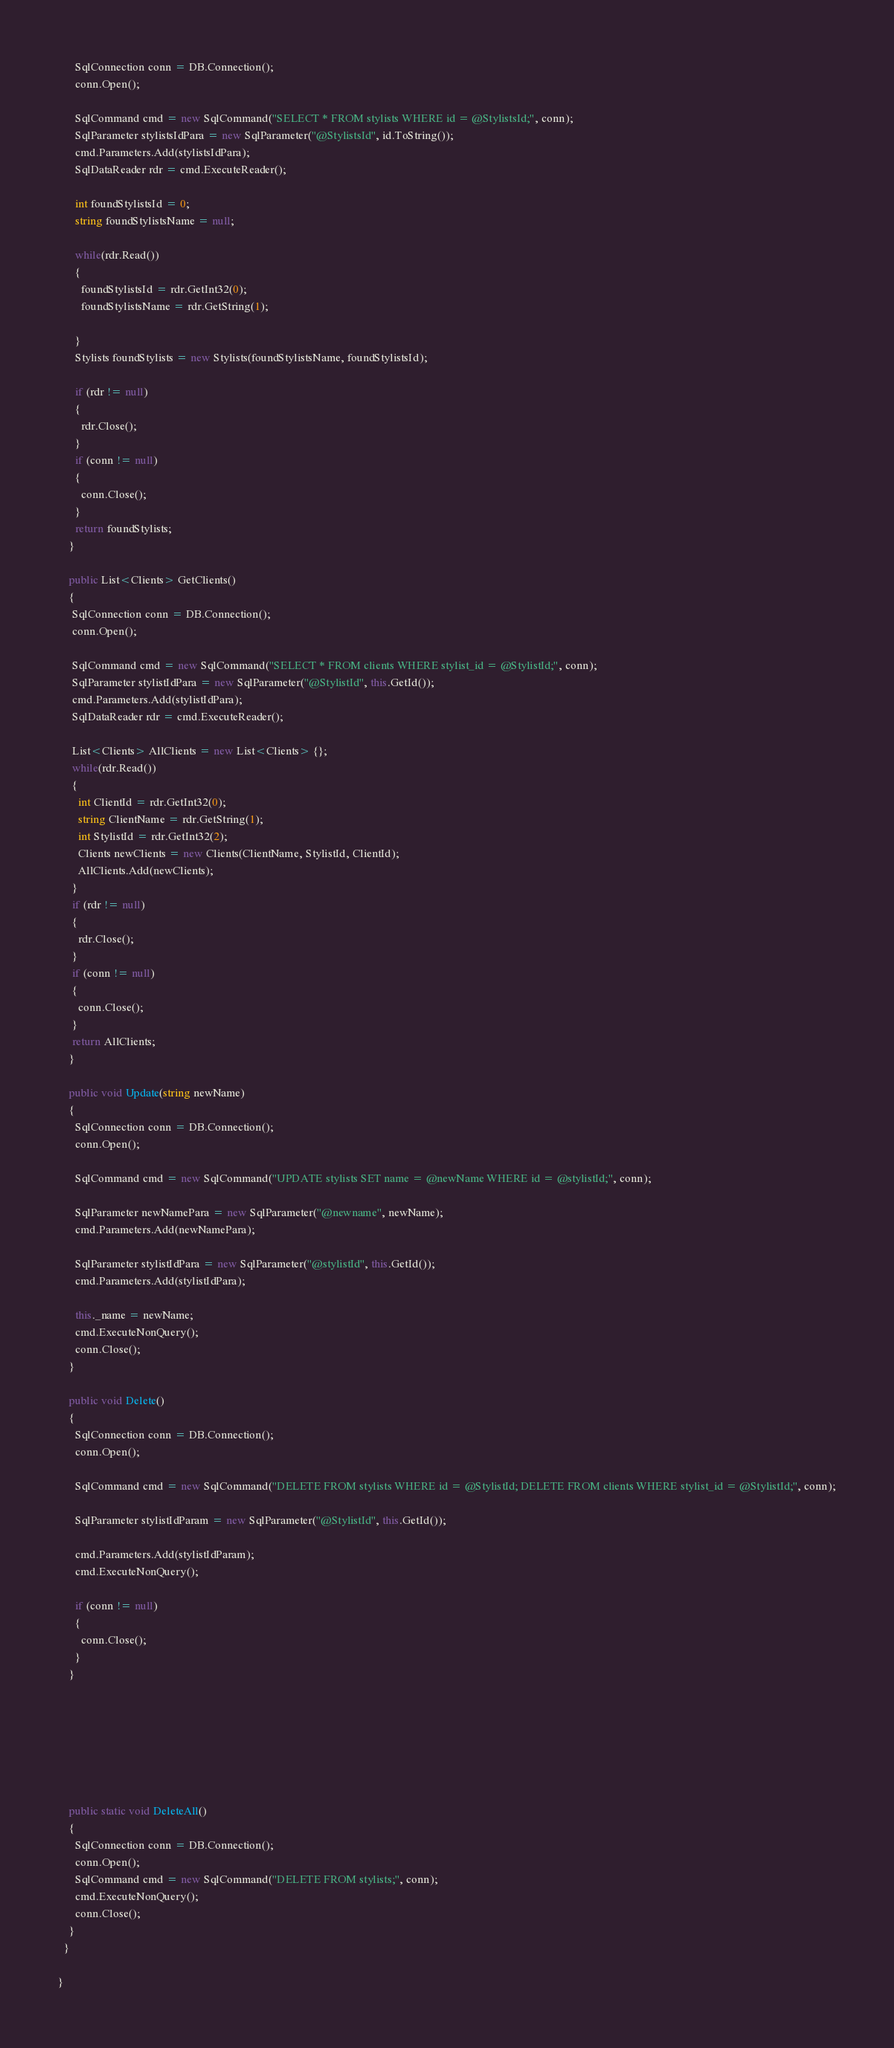<code> <loc_0><loc_0><loc_500><loc_500><_C#_>      SqlConnection conn = DB.Connection();
      conn.Open();

      SqlCommand cmd = new SqlCommand("SELECT * FROM stylists WHERE id = @StylistsId;", conn);
      SqlParameter stylistsIdPara = new SqlParameter("@StylistsId", id.ToString());
      cmd.Parameters.Add(stylistsIdPara);
      SqlDataReader rdr = cmd.ExecuteReader();

      int foundStylistsId = 0;
      string foundStylistsName = null;

      while(rdr.Read())
      {
        foundStylistsId = rdr.GetInt32(0);
        foundStylistsName = rdr.GetString(1);

      }
      Stylists foundStylists = new Stylists(foundStylistsName, foundStylistsId);

      if (rdr != null)
      {
        rdr.Close();
      }
      if (conn != null)
      {
        conn.Close();
      }
      return foundStylists;
    }

    public List<Clients> GetClients()
    {
     SqlConnection conn = DB.Connection();
     conn.Open();

     SqlCommand cmd = new SqlCommand("SELECT * FROM clients WHERE stylist_id = @StylistId;", conn);
     SqlParameter stylistIdPara = new SqlParameter("@StylistId", this.GetId());
     cmd.Parameters.Add(stylistIdPara);
     SqlDataReader rdr = cmd.ExecuteReader();

     List<Clients> AllClients = new List<Clients> {};
     while(rdr.Read())
     {
       int ClientId = rdr.GetInt32(0);
       string ClientName = rdr.GetString(1);
       int StylistId = rdr.GetInt32(2);
       Clients newClients = new Clients(ClientName, StylistId, ClientId);
       AllClients.Add(newClients);
     }
     if (rdr != null)
     {
       rdr.Close();
     }
     if (conn != null)
     {
       conn.Close();
     }
     return AllClients;
    }

    public void Update(string newName)
    {
      SqlConnection conn = DB.Connection();
      conn.Open();

      SqlCommand cmd = new SqlCommand("UPDATE stylists SET name = @newName WHERE id = @stylistId;", conn);

      SqlParameter newNamePara = new SqlParameter("@newname", newName);
      cmd.Parameters.Add(newNamePara);

      SqlParameter stylistIdPara = new SqlParameter("@stylistId", this.GetId());
      cmd.Parameters.Add(stylistIdPara);

      this._name = newName;
      cmd.ExecuteNonQuery();
      conn.Close();
    }

    public void Delete()
    {
      SqlConnection conn = DB.Connection();
      conn.Open();

      SqlCommand cmd = new SqlCommand("DELETE FROM stylists WHERE id = @StylistId; DELETE FROM clients WHERE stylist_id = @StylistId;", conn);

      SqlParameter stylistIdParam = new SqlParameter("@StylistId", this.GetId());

      cmd.Parameters.Add(stylistIdParam);
      cmd.ExecuteNonQuery();

      if (conn != null)
      {
        conn.Close();
      }
    }







    public static void DeleteAll()
    {
      SqlConnection conn = DB.Connection();
      conn.Open();
      SqlCommand cmd = new SqlCommand("DELETE FROM stylists;", conn);
      cmd.ExecuteNonQuery();
      conn.Close();
    }
  }

}
</code> 